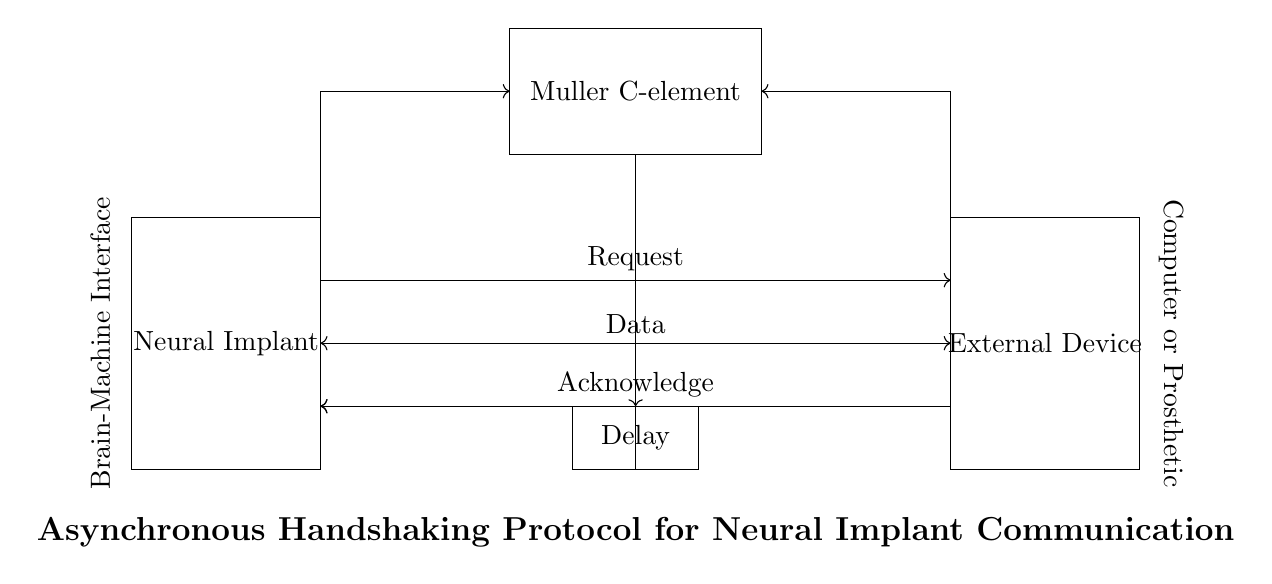What are the two main devices in the circuit? The circuit features a "Neural Implant" and an "External Device" as its primary components. These are the rectangular blocks depicted at each end of the diagram, indicating their roles in communication.
Answer: Neural Implant, External Device What type of element is used to facilitate the handshake? The Muller C-element is depicted in the circuit, which is specifically utilized for asynchronous handshaking. Its function is to combine multiple inputs to produce an output in digital circuits. This element is shown as a rectangle labeled "Muller C-element."
Answer: Muller C-element How many communication lines are depicted in the circuit? There are three communication lines: Request, Acknowledge, and Data. Each line is represented by arrows indicating the direction of data flow between the devices. This provides a clear idea of the nature of communication happening in the system.
Answer: Three What is the function of the Delay element in the circuit? The Delay element introduces a time lag between signals sent from the Muller C-element and the Acknowledge line. This helps in synchronizing communication between the Neural Implant and the External Device, ensuring smooth operation by matching the response time of the devices involved.
Answer: Synchronization Explain the direction of the Request line. The Request line is an outgoing signal from the Neural Implant towards the External Device, indicated by the rightward arrow in the circuit. This signifies that the Neural Implant is initiating communication or requesting actions from the External Device.
Answer: Outgoing signal Why is an asynchronous protocol implied in this circuit design? The circuit design depicts an asynchronous handshaking protocol where the timing of signals does not need to be synchronized with a clock signal. This is evidenced by the presence of the Muller C-element, which can operate independently of any clock cycles, allowing for flexible communication between the devices.
Answer: No clock synchronization 